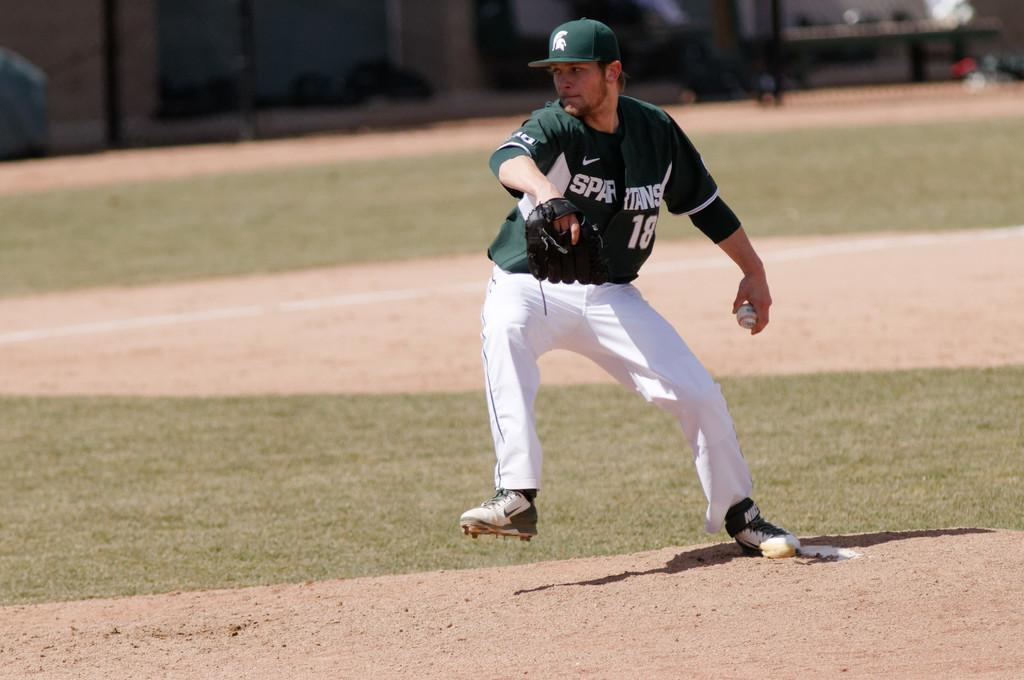<image>
Give a short and clear explanation of the subsequent image. a man wearing a green spartans jersey on the mound 